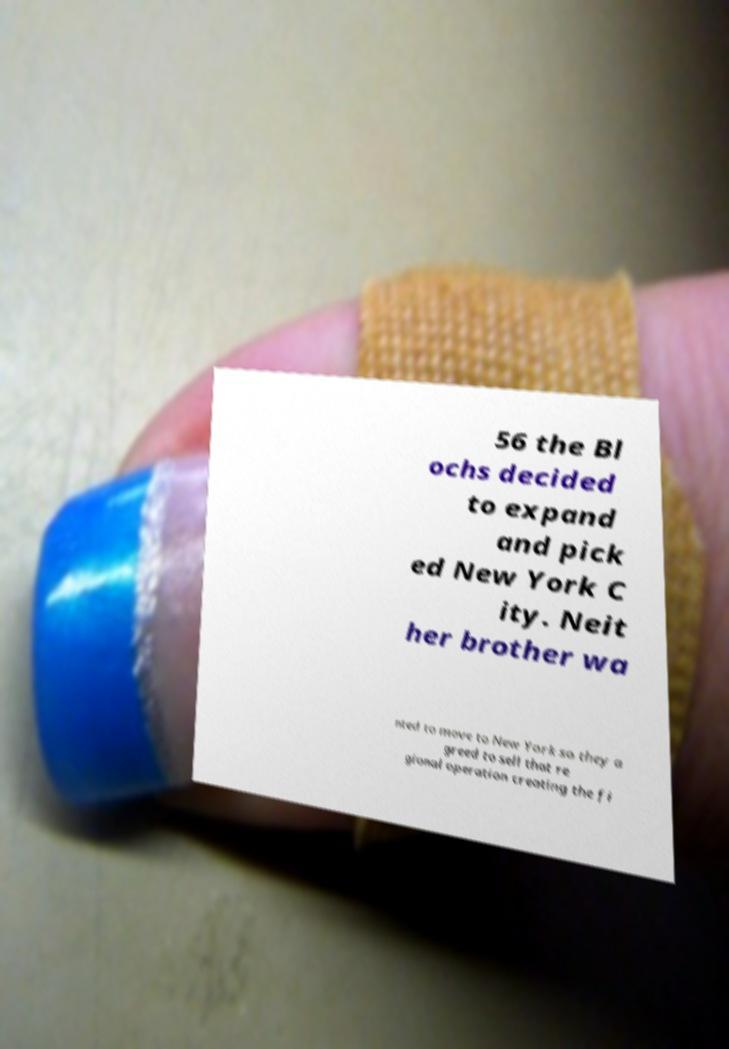There's text embedded in this image that I need extracted. Can you transcribe it verbatim? 56 the Bl ochs decided to expand and pick ed New York C ity. Neit her brother wa nted to move to New York so they a greed to sell that re gional operation creating the fi 